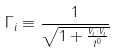Convert formula to latex. <formula><loc_0><loc_0><loc_500><loc_500>\Gamma _ { i } \equiv \frac { 1 } { \sqrt { 1 + \frac { v _ { i } \cdot v _ { i } } { t ^ { 0 } } } }</formula> 